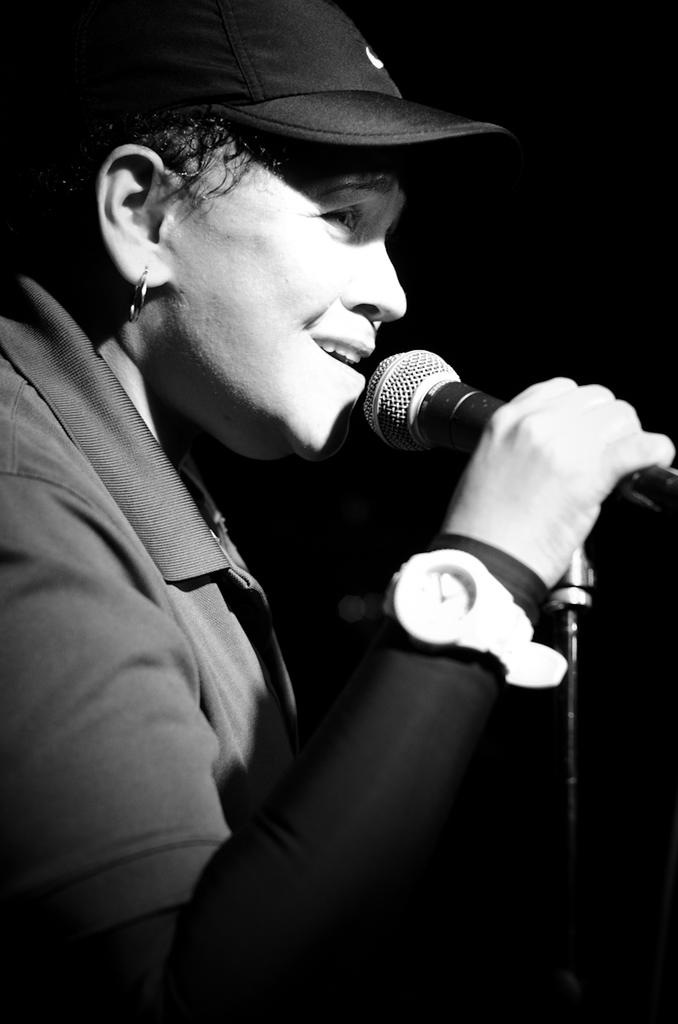What is the color scheme of the image? The image is black and white. Can you describe the person in the image? There is a person in the image. What is the person holding in the image? The person is holding a microphone. What type of bread is being used to support the microphone in the image? There is no bread present in the image, and the microphone is not being supported by any bread. 